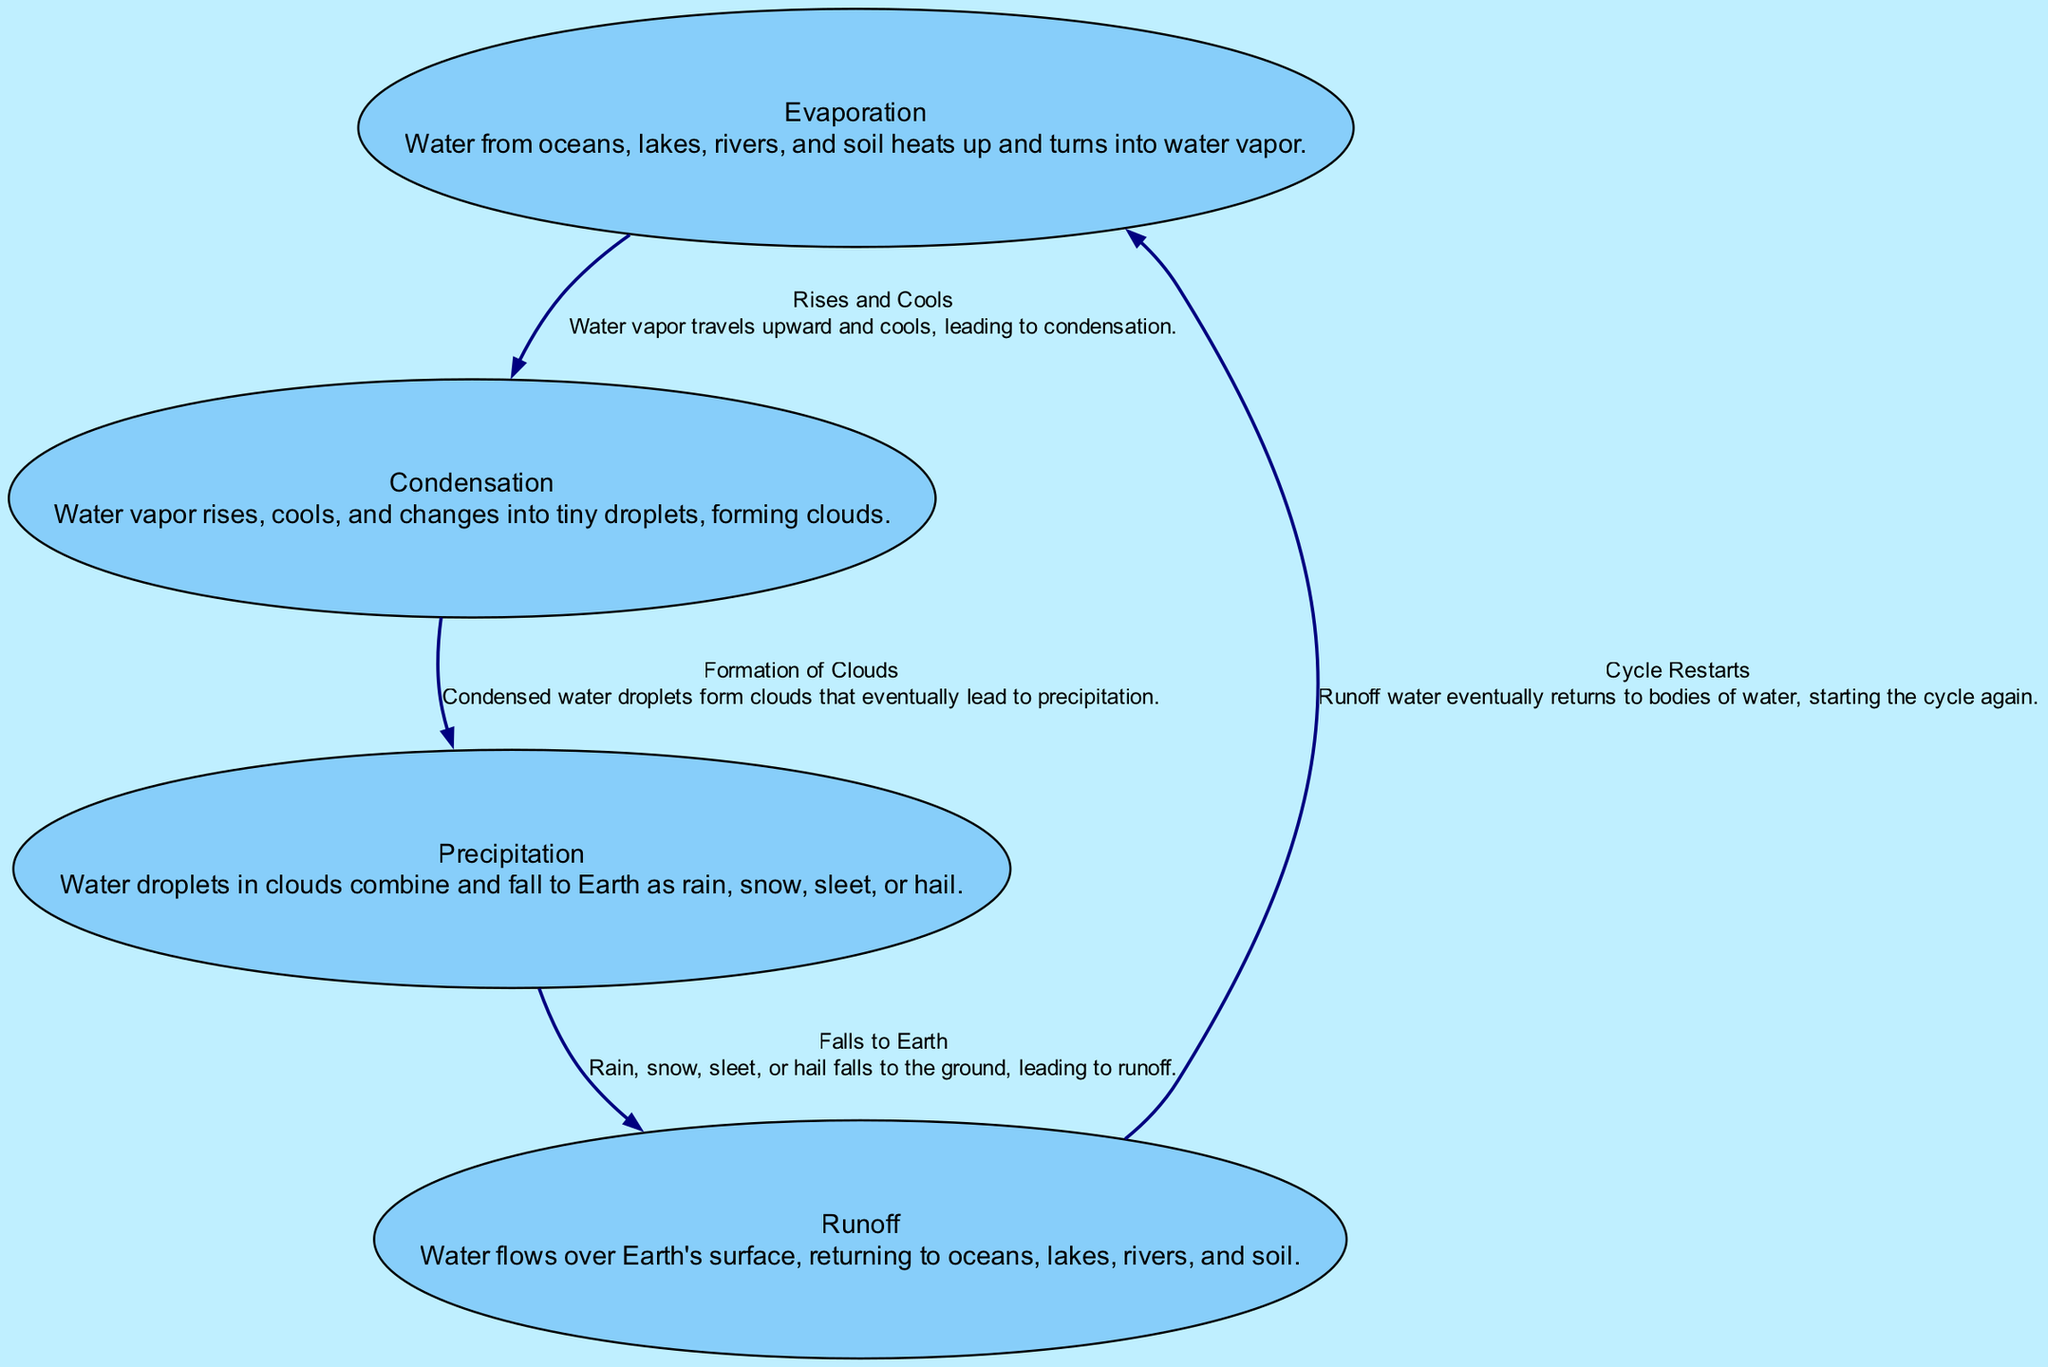What is the first phase of the water cycle? The diagram shows "Evaporation" as the starting node, indicating that water from various sources turns into vapor first.
Answer: Evaporation How many nodes are in the water cycle diagram? By counting the unique phases represented in the diagram, we find there are four nodes: Evaporation, Condensation, Precipitation, and Runoff.
Answer: Four What happens to water vapor as it rises? The edge connecting "Evaporation" to "Condensation" describes that water vapor rises and cools, which leads to the condensation process.
Answer: Rises and cools What is the result when condensation occurs? Following the edge from "Condensation" to "Precipitation," the process of condensation results in the formation of clouds and eventually leads to precipitation.
Answer: Formation of Clouds What type of precipitation can fall to the ground? The node "Precipitation" captures the different forms of water falling to Earth, which include rain, snow, sleet, or hail.
Answer: Rain, snow, sleet, or hail Which phase comes after precipitation? The diagram indicates that runoff follows precipitation, as seen from the directed edge leading to the "Runoff" node.
Answer: Runoff What is the function of runoff in the water cycle? The directed edge from "Runoff" to "Evaporation" indicates that runoff water returns to oceans, lakes, rivers, or soil, contributing to the cycle restarting.
Answer: Cycle Restarts Which phase is responsible for cloud formation? The diagram explicitly represents "Condensation" as the phase that involves the formation of clouds from water vapor turning into droplets.
Answer: Condensation How does evaporation contribute to the water cycle? The description in the node "Evaporation" explains that it is the initial phase that transforms water from various sources into vapor, starting the cycle.
Answer: Water vapor transforms What completes the water cycle process shown in the diagram? By examining the connections, the entire cycle helps complete itself by the runoff returning water to lakes, oceans, and soil, leading back to evaporation.
Answer: Returns to evaporation 